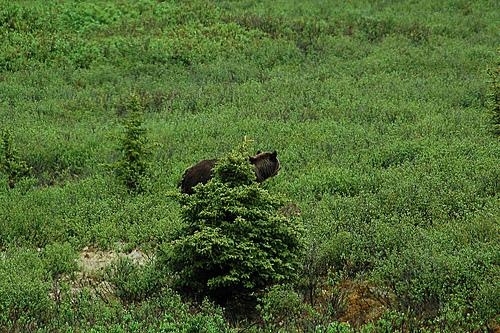Explain the overall atmosphere of the image. The image represents a natural green landscape where a wild brown bear is in its element, surrounded by trees, plants, and vegetation. What are the colors of plants present in the image? The plants in the image are green in color. What color is the bear in the image, and what is notable about its appearance? The bear is black in color with dark brown fur, two small rounded ears, thick brown fur, and an open mouth. Describe the state of the bear's mouth and ears in the image. The bear has an open mouth and two small rounded ears. Select one task from the list and answer it: Referential expression grounding task. The task is to describe the bear's appearance in detail. The bear is large, black in color, with dark brown rugged fur, two small rounded ears, thick brown fur, and an open mouth. Provide a detailed overview of the image. The image showcases a natural green landscape featuring a large black bear, several green plants and trees, as well as patches of dirt and some branches. Identify the primary element in the image and its features. A bear, large and black in color, is the main element in the image, with dark brown fur, rugged texture, and a visibly open mouth. Mention a few features of the plants present in the image. The plants are green in color, small in size, and exist in large amounts across the image. What type of vegetation can be seen in the image, and what are their characteristics? The image features small vegetations that are green in color and vary in size. Describe the trees found in the image. The trees in the image are green, small in size, and have brown branches. Some of them are young evergreen trees, and others are short and wide. 